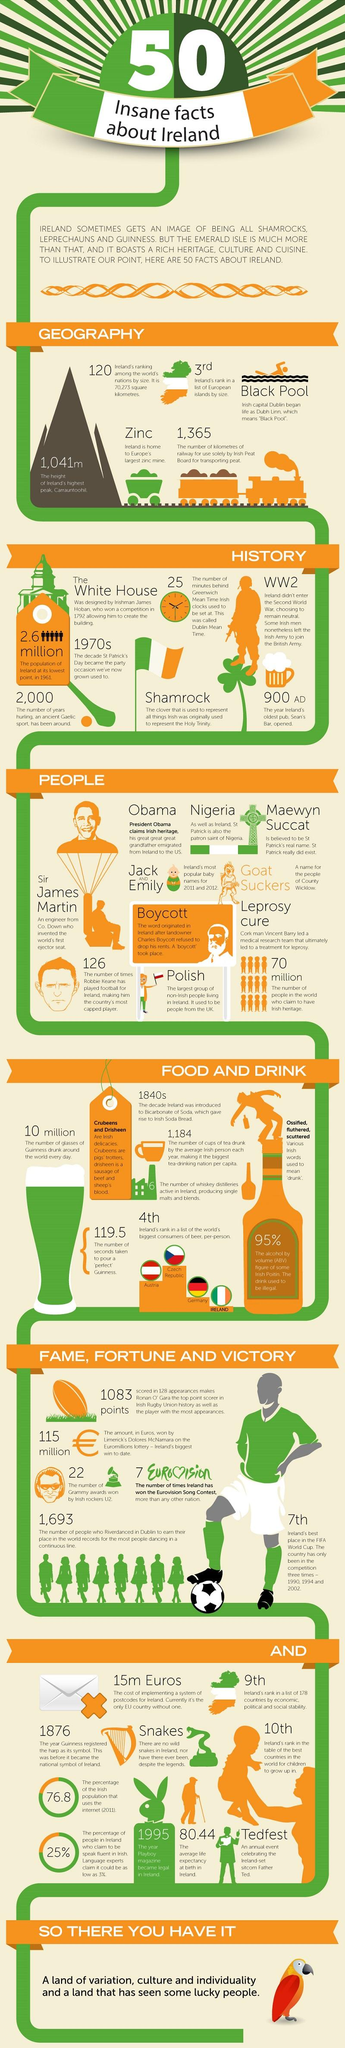Indicate a few pertinent items in this graphic. There are approximately 70 million people in the world who claim Irish heritage. The mountain known as Carrauntoohil is the highest on the island of Ireland. The highest peak in Ireland is 1,041 meters tall. Jack and Emily were the two most popular baby names in Ireland during the years 2011 and 2012. Snake reptiles are not found on the island of Ireland. 